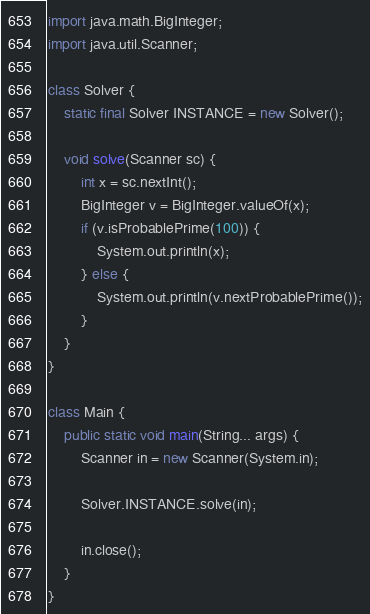Convert code to text. <code><loc_0><loc_0><loc_500><loc_500><_Java_>import java.math.BigInteger;
import java.util.Scanner;

class Solver {
	static final Solver INSTANCE = new Solver();

	void solve(Scanner sc) {
		int x = sc.nextInt();
		BigInteger v = BigInteger.valueOf(x);
		if (v.isProbablePrime(100)) {
			System.out.println(x);
		} else {
			System.out.println(v.nextProbablePrime());
		}
	}
}

class Main {
	public static void main(String... args) {
		Scanner in = new Scanner(System.in);

		Solver.INSTANCE.solve(in);

		in.close();
	}
}</code> 